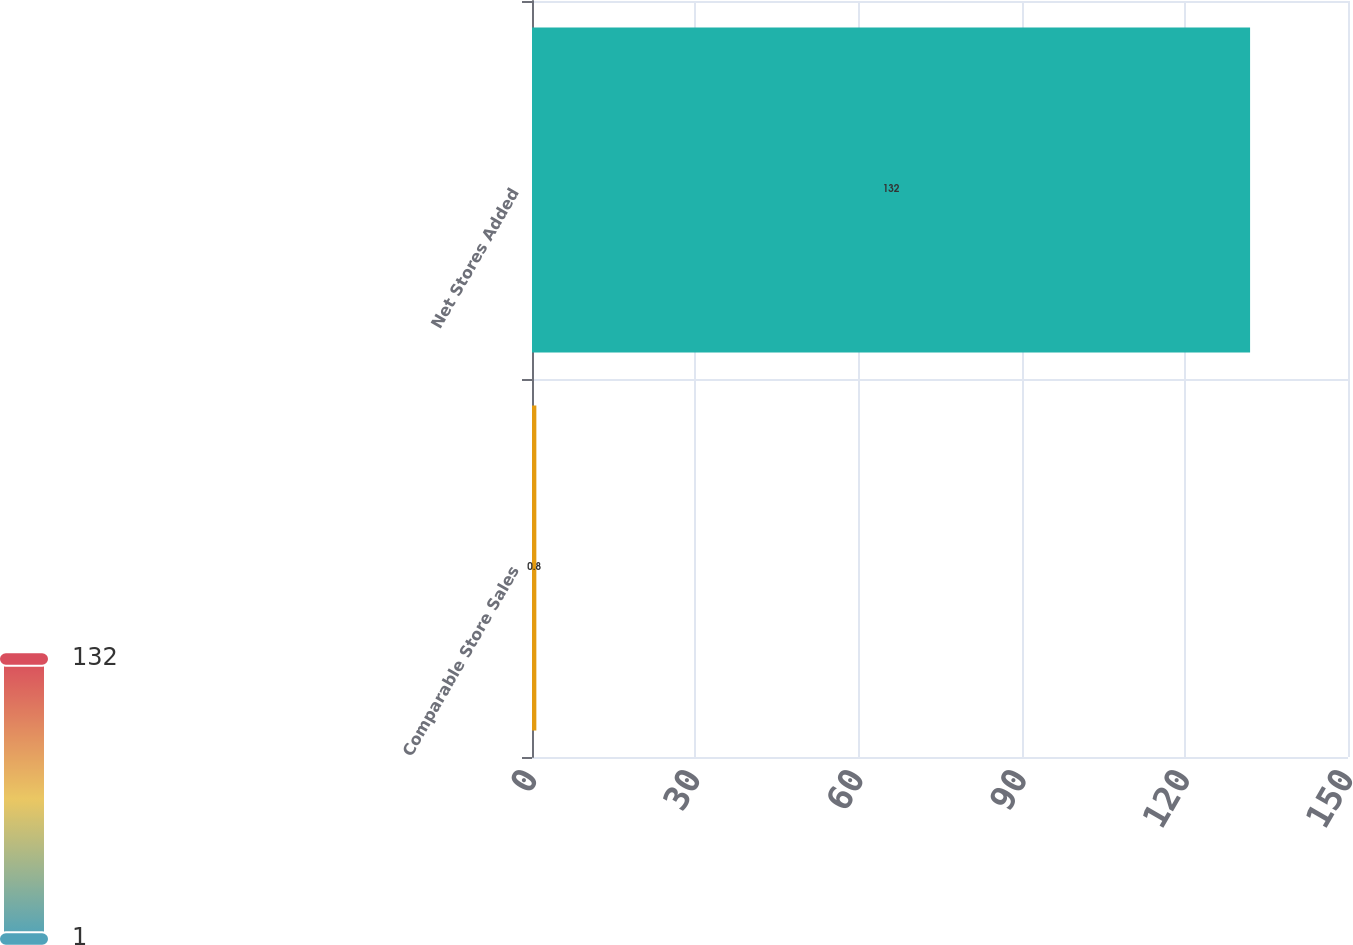Convert chart. <chart><loc_0><loc_0><loc_500><loc_500><bar_chart><fcel>Comparable Store Sales<fcel>Net Stores Added<nl><fcel>0.8<fcel>132<nl></chart> 